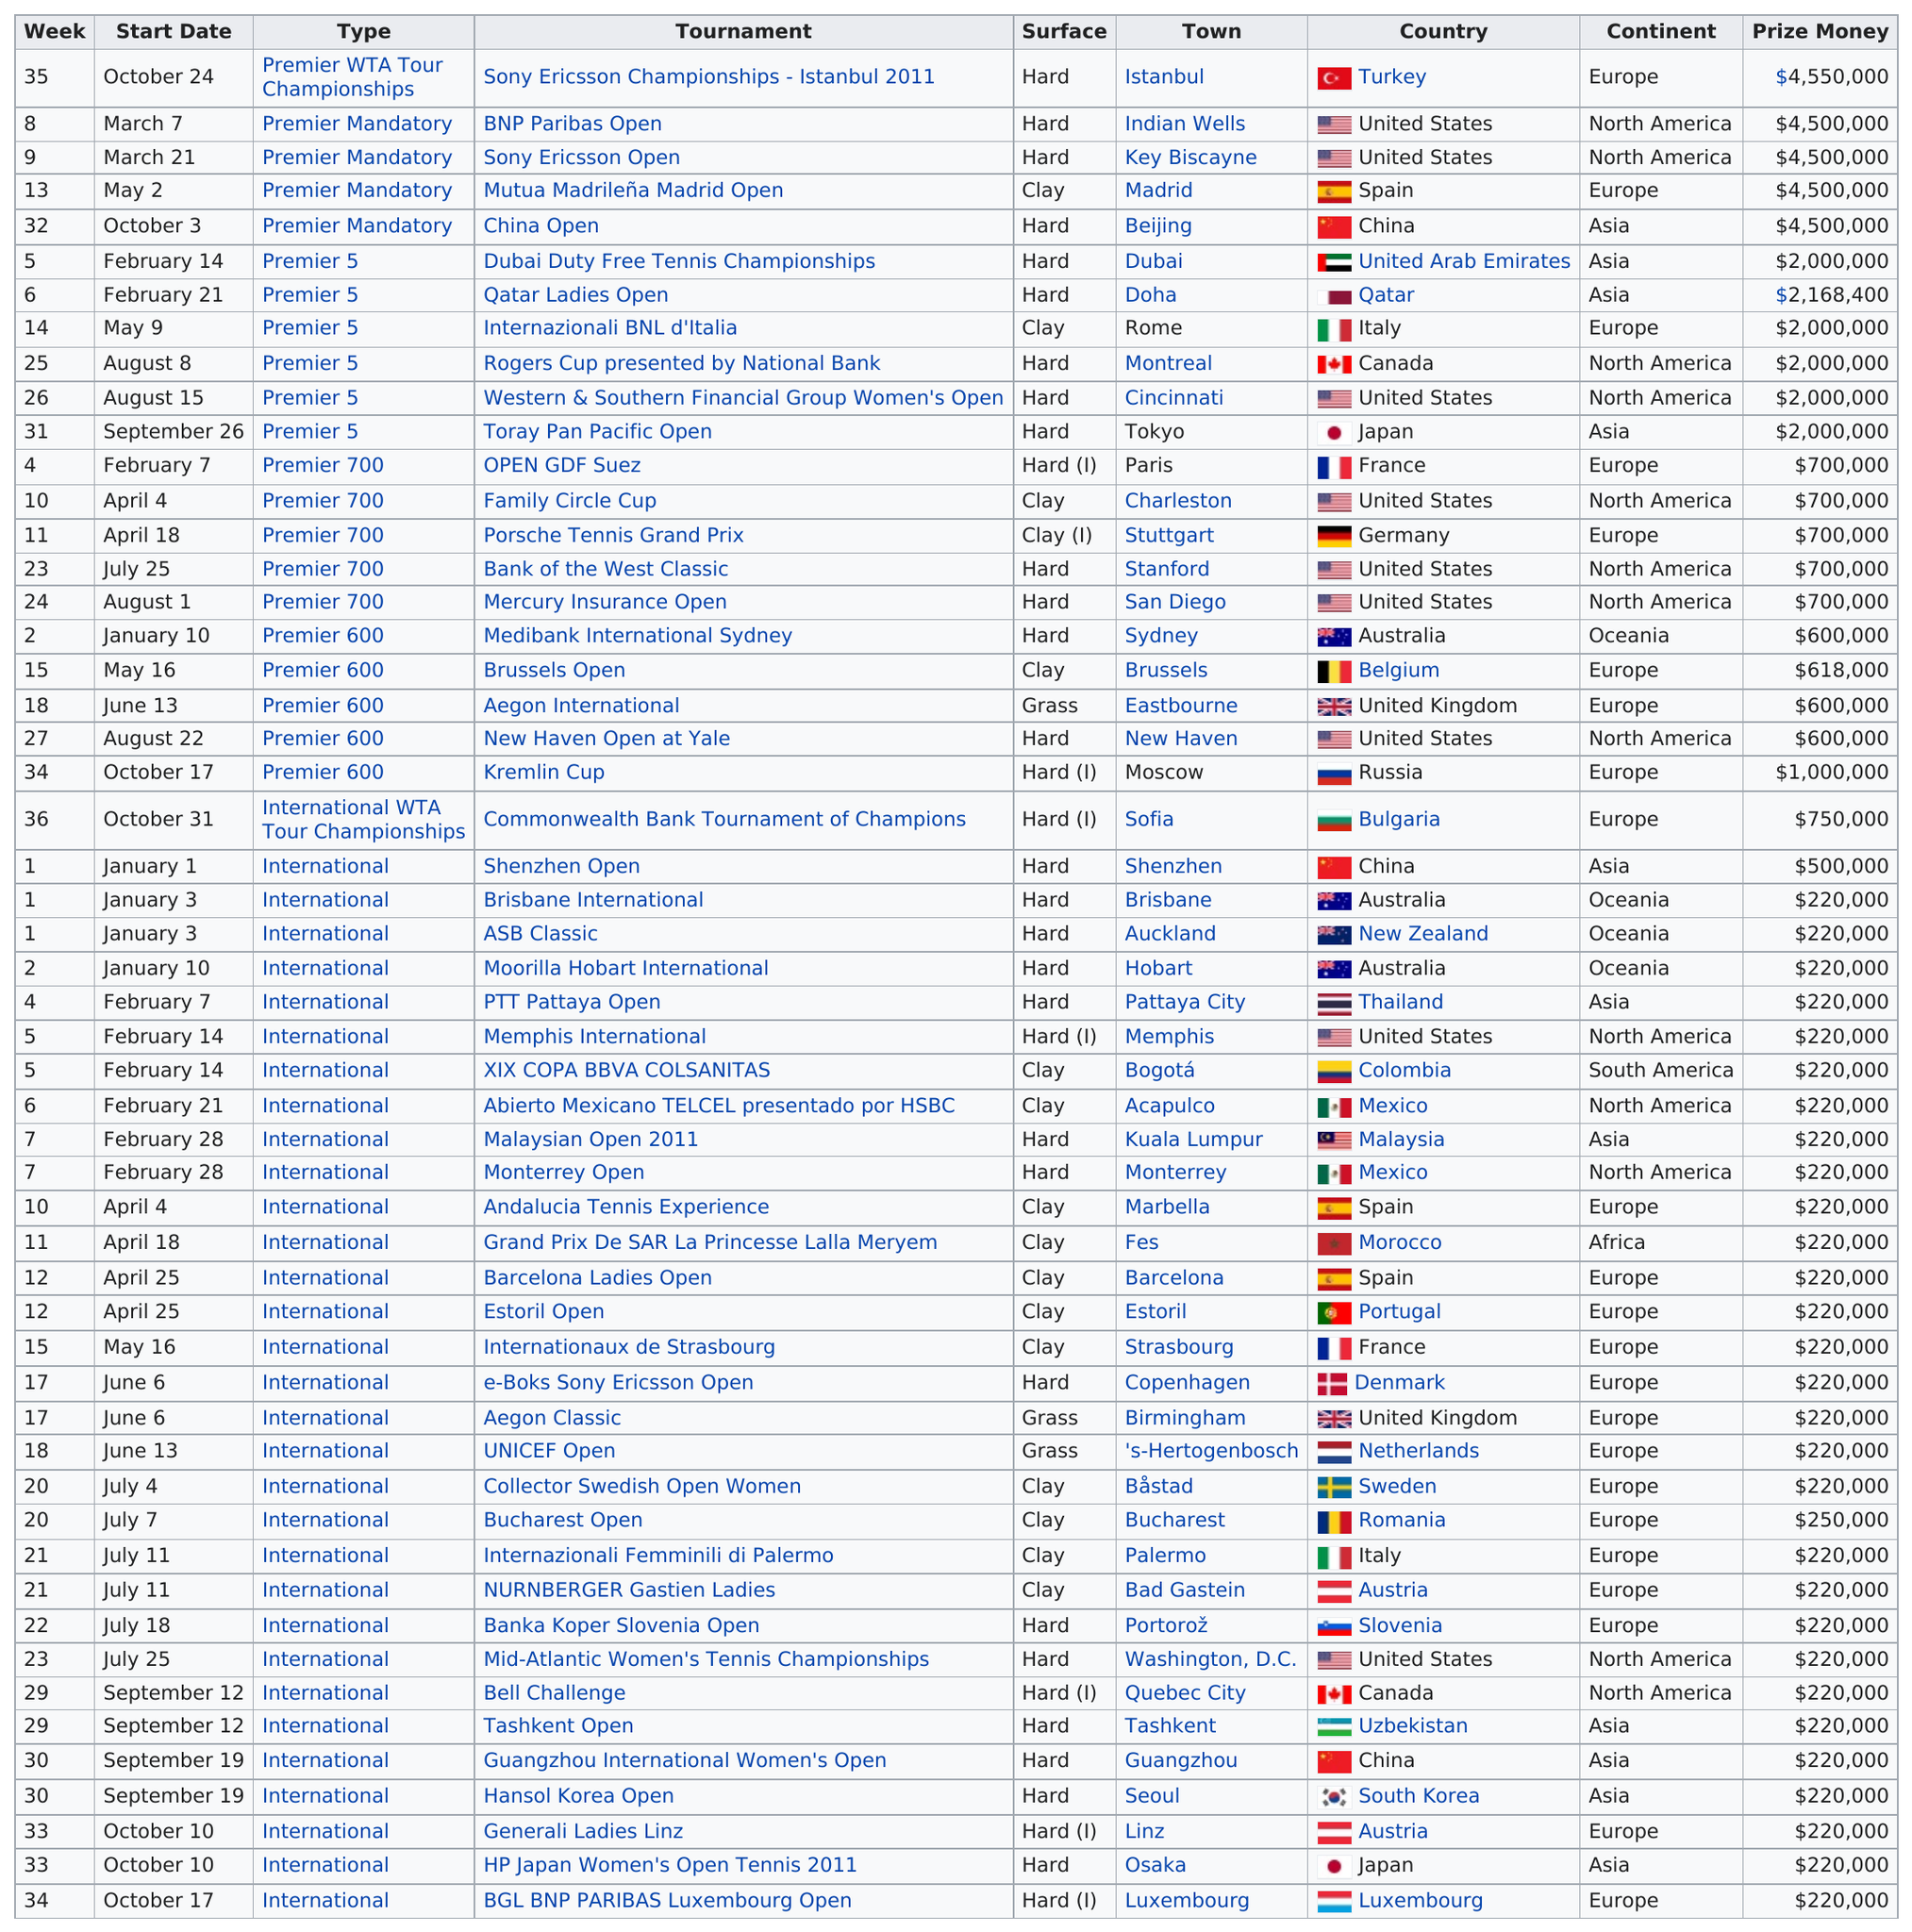Give some essential details in this illustration. There have been a total of 3 tournaments that have been played on grass. Europe has hosted more frequently than Asia. The Sony Ericsson Championships - Istanbul 2011 was the tournament that preceded the BNP Paribas Open. The family circle cup is preceded by the GDF Suez tournament, which is a prestigious open-level event. The BGL BNP PARIBAS Luxembourg Open is the last tournament of the year. 